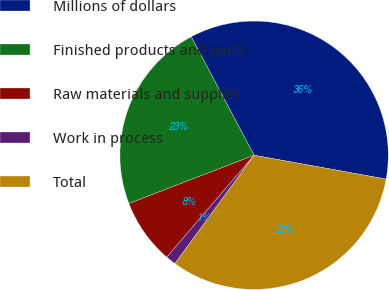Convert chart to OTSL. <chart><loc_0><loc_0><loc_500><loc_500><pie_chart><fcel>Millions of dollars<fcel>Finished products and parts<fcel>Raw materials and supplies<fcel>Work in process<fcel>Total<nl><fcel>35.61%<fcel>23.11%<fcel>7.86%<fcel>1.23%<fcel>32.2%<nl></chart> 